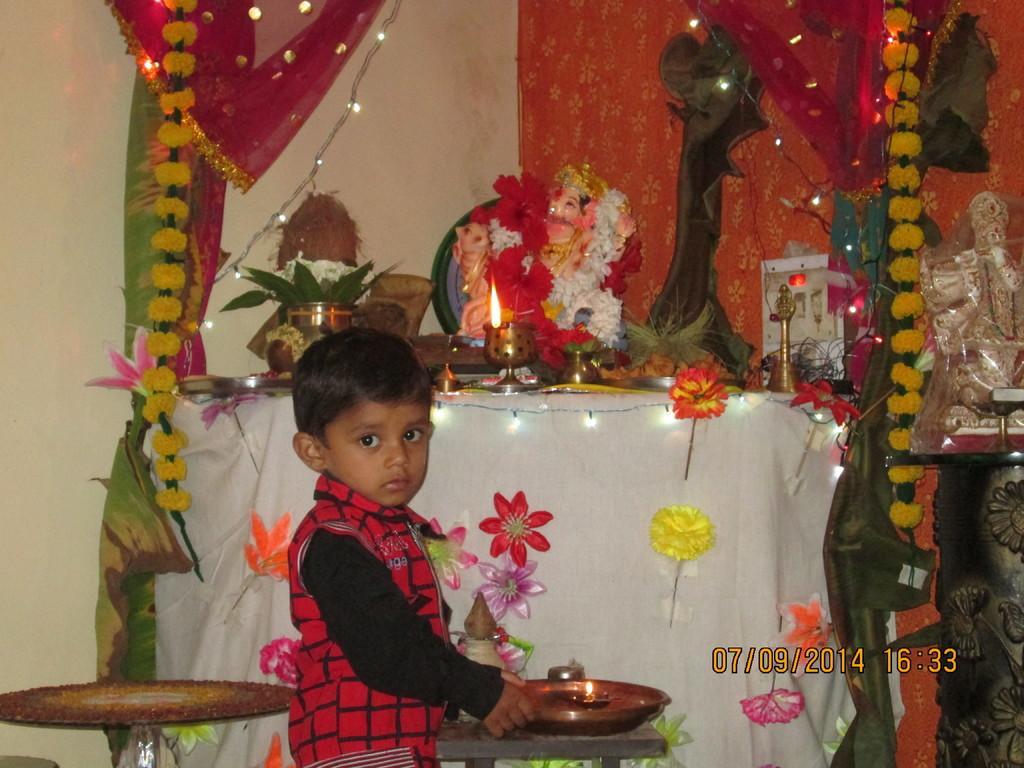In one or two sentences, can you explain what this image depicts? In this image I can see a boy wearing red and black colored dress is standing and holding a plate in his hands. In the background I can see a white colored cloth on which I can see flowers which are yellow and red in color, few lamps, a statue and on the statue I can see few flowers which are red and white in color, the orange colored cloth, the white colored wall and few lights. 